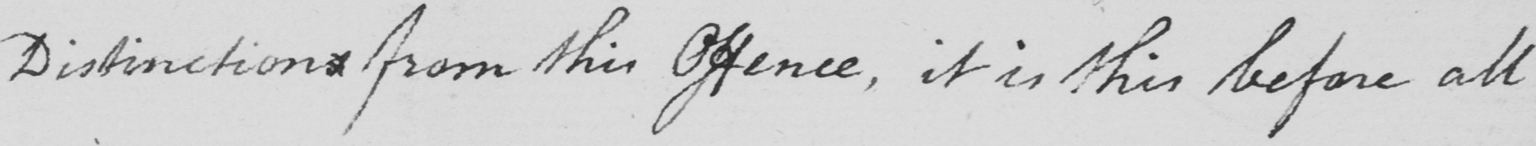What does this handwritten line say? Distinctions from this Offence , it is this before all 